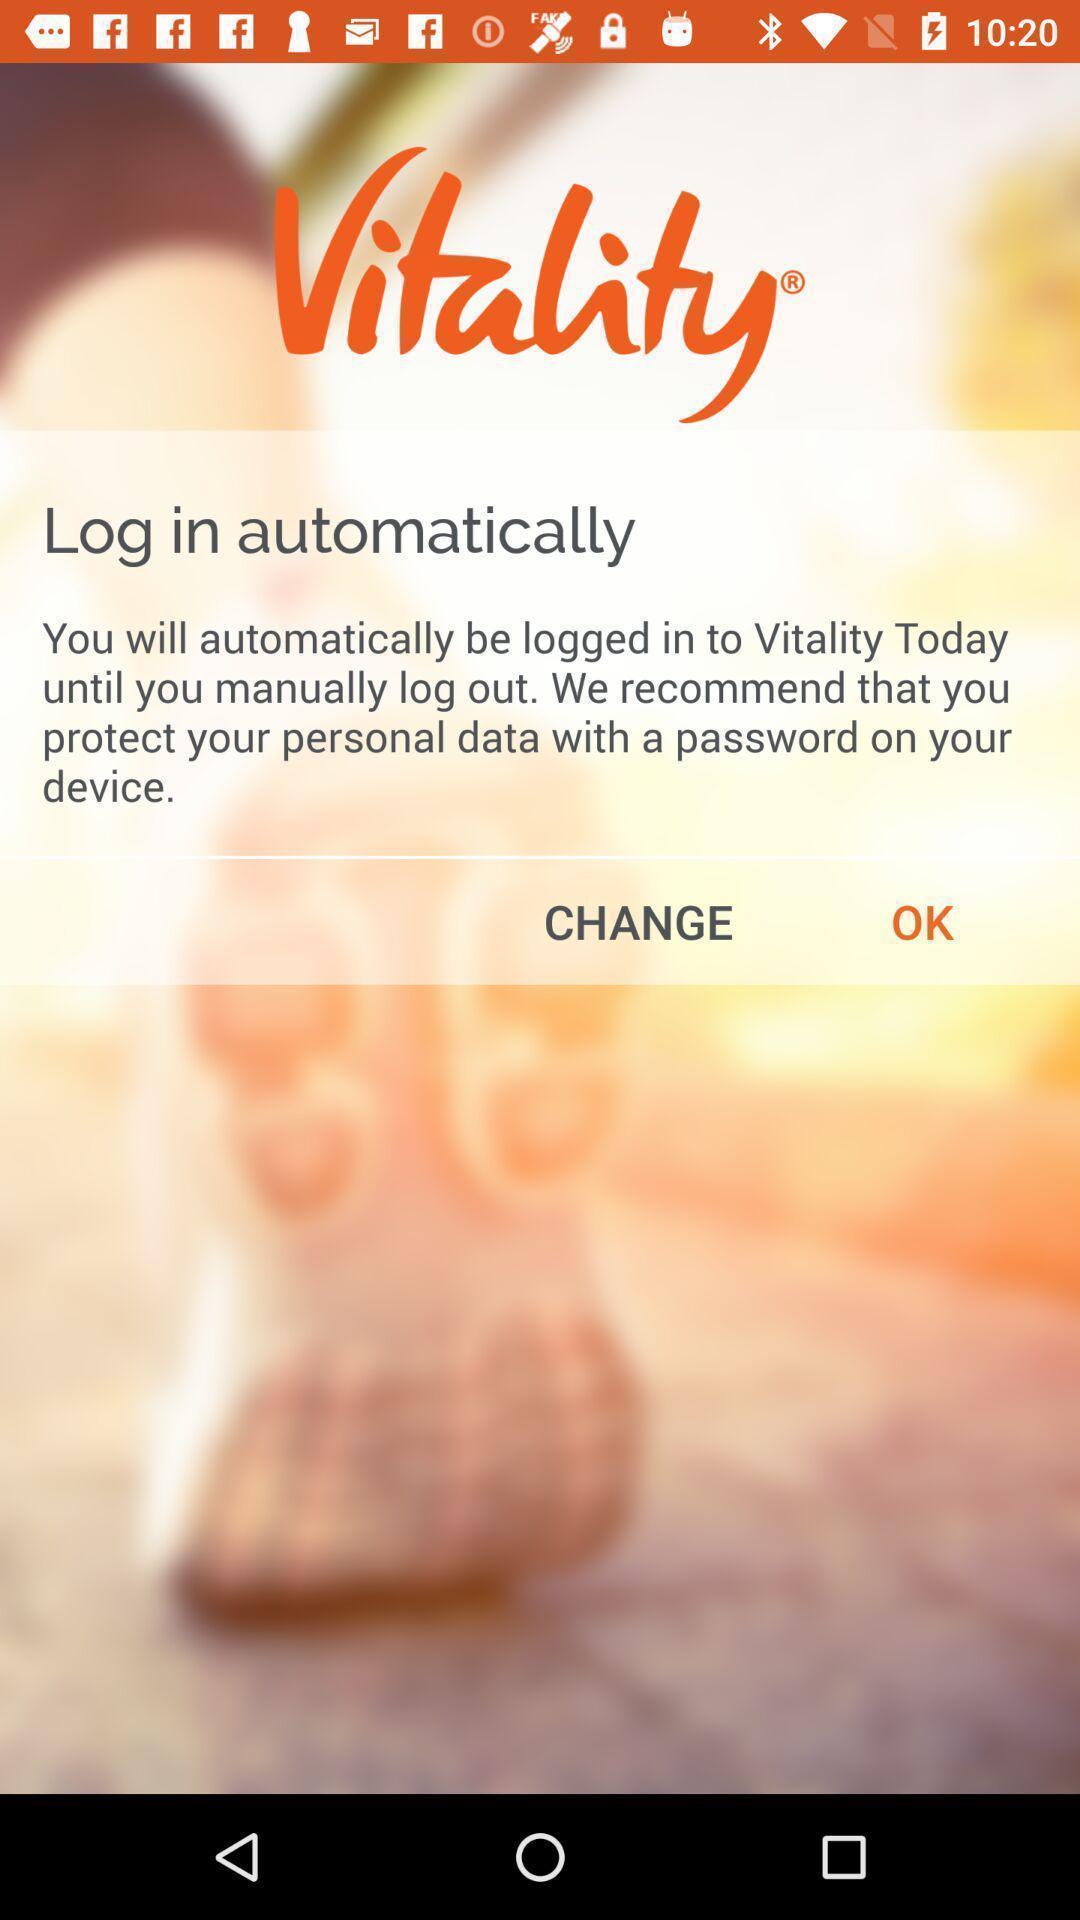Give me a summary of this screen capture. Welcome screen. 